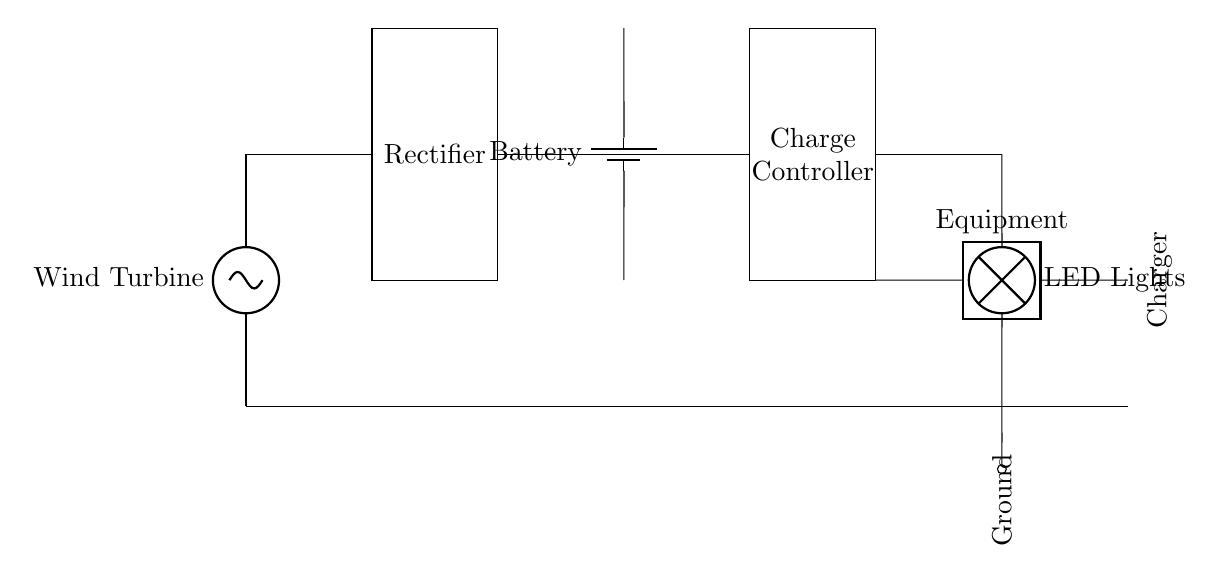What is the primary source of power in this circuit? The circuit uses a wind turbine as the primary source of power, which is indicated at the beginning of the diagram with the label "Wind Turbine."
Answer: Wind Turbine What component converts AC to DC? The component that converts alternating current (AC) to direct current (DC) in this circuit is a rectifier, as drawn in the diagram and labeled accordingly.
Answer: Rectifier How many main components are used for charging? There are three main components used for charging: the battery, the charge controller, and the equipment charger, as indicated in the schematic.
Answer: Three What type of lights are being used in the circuit? The circuit uses LED lights, which are specified in the diagram with the label "LED Lights."
Answer: LED Lights What device regulates the charging process? The charge controller regulates the charging process by controlling the electricity flow from the battery to the load, which is shown as the labeled component in the circuit diagram.
Answer: Charge Controller How is the ground represented in the circuit? The ground is represented by a horizontal line at the bottom of the circuit, with one label indicating "Ground" at the end of the connection.
Answer: Ground What is the purpose of the battery in this circuit? The battery acts as a storage device that holds the electrical energy generated by the wind turbine for later use, particularly for powering lights and charging equipment overnight.
Answer: Storage device 